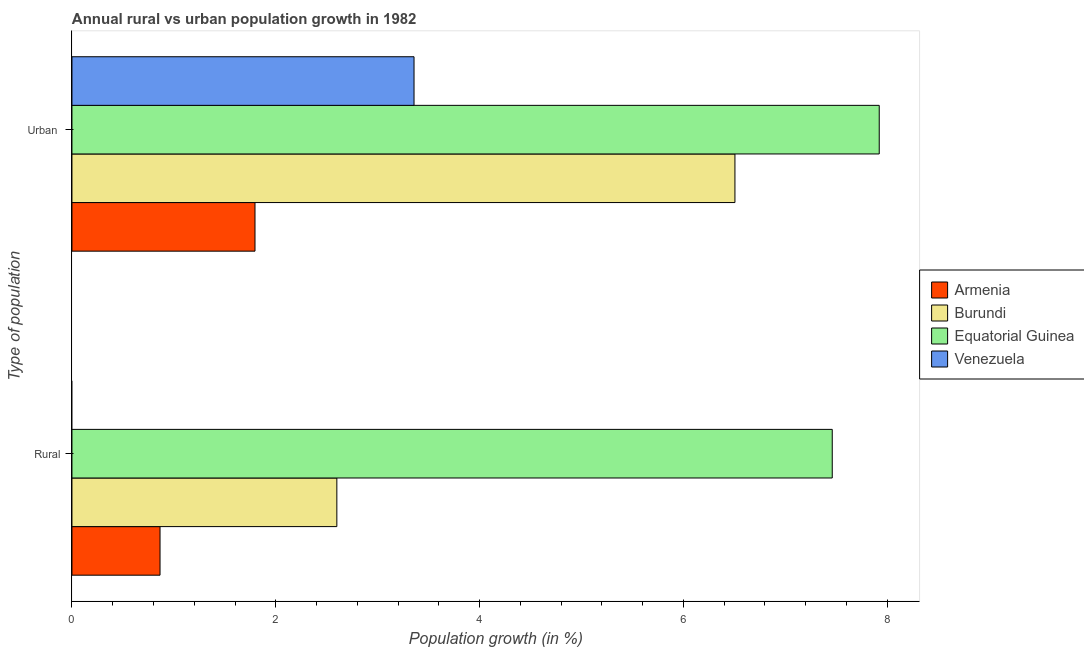How many groups of bars are there?
Ensure brevity in your answer.  2. Are the number of bars on each tick of the Y-axis equal?
Offer a very short reply. No. What is the label of the 2nd group of bars from the top?
Keep it short and to the point. Rural. What is the urban population growth in Armenia?
Offer a very short reply. 1.8. Across all countries, what is the maximum rural population growth?
Your answer should be compact. 7.46. Across all countries, what is the minimum urban population growth?
Your answer should be very brief. 1.8. In which country was the rural population growth maximum?
Your answer should be very brief. Equatorial Guinea. What is the total rural population growth in the graph?
Offer a very short reply. 10.92. What is the difference between the rural population growth in Burundi and that in Armenia?
Your answer should be very brief. 1.73. What is the difference between the urban population growth in Armenia and the rural population growth in Equatorial Guinea?
Ensure brevity in your answer.  -5.66. What is the average urban population growth per country?
Your response must be concise. 4.9. What is the difference between the rural population growth and urban population growth in Equatorial Guinea?
Your answer should be compact. -0.46. What is the ratio of the urban population growth in Venezuela to that in Equatorial Guinea?
Your answer should be very brief. 0.42. Is the urban population growth in Venezuela less than that in Burundi?
Your answer should be very brief. Yes. In how many countries, is the rural population growth greater than the average rural population growth taken over all countries?
Keep it short and to the point. 1. What is the difference between two consecutive major ticks on the X-axis?
Provide a succinct answer. 2. Are the values on the major ticks of X-axis written in scientific E-notation?
Offer a very short reply. No. Where does the legend appear in the graph?
Give a very brief answer. Center right. What is the title of the graph?
Make the answer very short. Annual rural vs urban population growth in 1982. Does "Yemen, Rep." appear as one of the legend labels in the graph?
Give a very brief answer. No. What is the label or title of the X-axis?
Make the answer very short. Population growth (in %). What is the label or title of the Y-axis?
Offer a very short reply. Type of population. What is the Population growth (in %) in Armenia in Rural?
Make the answer very short. 0.86. What is the Population growth (in %) in Burundi in Rural?
Ensure brevity in your answer.  2.6. What is the Population growth (in %) of Equatorial Guinea in Rural?
Your answer should be very brief. 7.46. What is the Population growth (in %) in Armenia in Urban ?
Offer a very short reply. 1.8. What is the Population growth (in %) in Burundi in Urban ?
Your response must be concise. 6.51. What is the Population growth (in %) in Equatorial Guinea in Urban ?
Your answer should be compact. 7.92. What is the Population growth (in %) in Venezuela in Urban ?
Ensure brevity in your answer.  3.36. Across all Type of population, what is the maximum Population growth (in %) of Armenia?
Your answer should be compact. 1.8. Across all Type of population, what is the maximum Population growth (in %) of Burundi?
Ensure brevity in your answer.  6.51. Across all Type of population, what is the maximum Population growth (in %) in Equatorial Guinea?
Provide a succinct answer. 7.92. Across all Type of population, what is the maximum Population growth (in %) in Venezuela?
Ensure brevity in your answer.  3.36. Across all Type of population, what is the minimum Population growth (in %) of Armenia?
Offer a very short reply. 0.86. Across all Type of population, what is the minimum Population growth (in %) of Burundi?
Ensure brevity in your answer.  2.6. Across all Type of population, what is the minimum Population growth (in %) of Equatorial Guinea?
Provide a succinct answer. 7.46. Across all Type of population, what is the minimum Population growth (in %) of Venezuela?
Your answer should be compact. 0. What is the total Population growth (in %) of Armenia in the graph?
Offer a very short reply. 2.66. What is the total Population growth (in %) of Burundi in the graph?
Give a very brief answer. 9.1. What is the total Population growth (in %) in Equatorial Guinea in the graph?
Give a very brief answer. 15.38. What is the total Population growth (in %) of Venezuela in the graph?
Offer a terse response. 3.36. What is the difference between the Population growth (in %) of Armenia in Rural and that in Urban ?
Offer a terse response. -0.93. What is the difference between the Population growth (in %) in Burundi in Rural and that in Urban ?
Give a very brief answer. -3.91. What is the difference between the Population growth (in %) in Equatorial Guinea in Rural and that in Urban ?
Your answer should be compact. -0.46. What is the difference between the Population growth (in %) in Armenia in Rural and the Population growth (in %) in Burundi in Urban ?
Offer a very short reply. -5.64. What is the difference between the Population growth (in %) in Armenia in Rural and the Population growth (in %) in Equatorial Guinea in Urban ?
Keep it short and to the point. -7.06. What is the difference between the Population growth (in %) in Armenia in Rural and the Population growth (in %) in Venezuela in Urban ?
Your answer should be compact. -2.49. What is the difference between the Population growth (in %) in Burundi in Rural and the Population growth (in %) in Equatorial Guinea in Urban ?
Your answer should be compact. -5.32. What is the difference between the Population growth (in %) of Burundi in Rural and the Population growth (in %) of Venezuela in Urban ?
Your answer should be very brief. -0.76. What is the difference between the Population growth (in %) of Equatorial Guinea in Rural and the Population growth (in %) of Venezuela in Urban ?
Offer a terse response. 4.1. What is the average Population growth (in %) of Armenia per Type of population?
Your response must be concise. 1.33. What is the average Population growth (in %) in Burundi per Type of population?
Provide a succinct answer. 4.55. What is the average Population growth (in %) of Equatorial Guinea per Type of population?
Your response must be concise. 7.69. What is the average Population growth (in %) of Venezuela per Type of population?
Offer a terse response. 1.68. What is the difference between the Population growth (in %) in Armenia and Population growth (in %) in Burundi in Rural?
Ensure brevity in your answer.  -1.73. What is the difference between the Population growth (in %) in Armenia and Population growth (in %) in Equatorial Guinea in Rural?
Your response must be concise. -6.6. What is the difference between the Population growth (in %) in Burundi and Population growth (in %) in Equatorial Guinea in Rural?
Provide a succinct answer. -4.86. What is the difference between the Population growth (in %) of Armenia and Population growth (in %) of Burundi in Urban ?
Your answer should be compact. -4.71. What is the difference between the Population growth (in %) in Armenia and Population growth (in %) in Equatorial Guinea in Urban ?
Offer a very short reply. -6.13. What is the difference between the Population growth (in %) of Armenia and Population growth (in %) of Venezuela in Urban ?
Ensure brevity in your answer.  -1.56. What is the difference between the Population growth (in %) in Burundi and Population growth (in %) in Equatorial Guinea in Urban ?
Ensure brevity in your answer.  -1.42. What is the difference between the Population growth (in %) of Burundi and Population growth (in %) of Venezuela in Urban ?
Your response must be concise. 3.15. What is the difference between the Population growth (in %) of Equatorial Guinea and Population growth (in %) of Venezuela in Urban ?
Give a very brief answer. 4.56. What is the ratio of the Population growth (in %) of Armenia in Rural to that in Urban ?
Your answer should be very brief. 0.48. What is the ratio of the Population growth (in %) of Burundi in Rural to that in Urban ?
Your answer should be compact. 0.4. What is the ratio of the Population growth (in %) in Equatorial Guinea in Rural to that in Urban ?
Provide a short and direct response. 0.94. What is the difference between the highest and the second highest Population growth (in %) of Armenia?
Offer a very short reply. 0.93. What is the difference between the highest and the second highest Population growth (in %) in Burundi?
Your answer should be very brief. 3.91. What is the difference between the highest and the second highest Population growth (in %) in Equatorial Guinea?
Ensure brevity in your answer.  0.46. What is the difference between the highest and the lowest Population growth (in %) of Armenia?
Offer a terse response. 0.93. What is the difference between the highest and the lowest Population growth (in %) of Burundi?
Your answer should be compact. 3.91. What is the difference between the highest and the lowest Population growth (in %) in Equatorial Guinea?
Provide a succinct answer. 0.46. What is the difference between the highest and the lowest Population growth (in %) in Venezuela?
Your response must be concise. 3.36. 